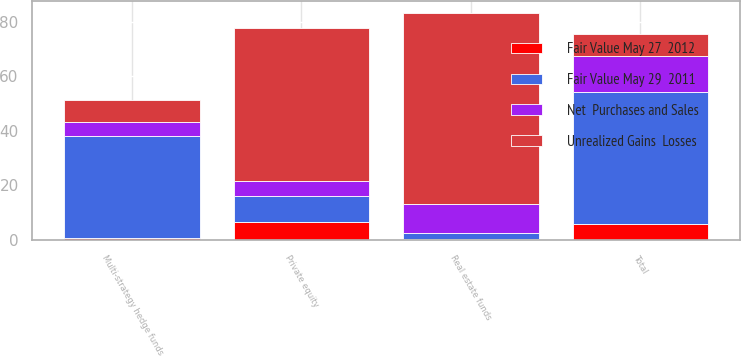<chart> <loc_0><loc_0><loc_500><loc_500><stacked_bar_chart><ecel><fcel>Real estate funds<fcel>Multi-strategy hedge funds<fcel>Private equity<fcel>Total<nl><fcel>Unrealized Gains  Losses<fcel>70.3<fcel>7.95<fcel>56<fcel>7.95<nl><fcel>Fair Value May 27  2012<fcel>0.3<fcel>0.6<fcel>6.7<fcel>5.8<nl><fcel>Fair Value May 29  2011<fcel>2.1<fcel>37.6<fcel>9.2<fcel>48.4<nl><fcel>Net  Purchases and Sales<fcel>10.6<fcel>5.1<fcel>5.7<fcel>13.2<nl></chart> 